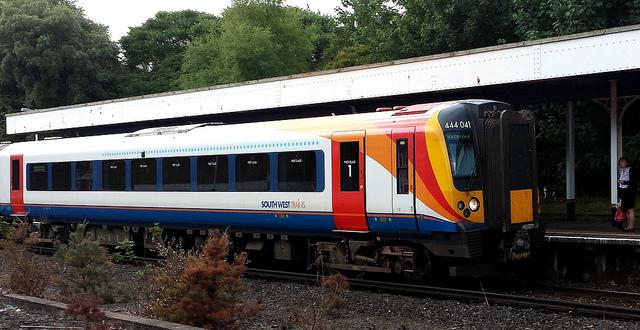What type of vehicle is pictured here?
Write a very short answer. Train. What color is the train?
Give a very brief answer. White. What is a likely explanation for the evergreen trees in the picture being brown?
Short answer required. Drought. Is the train at the station?
Keep it brief. Yes. 